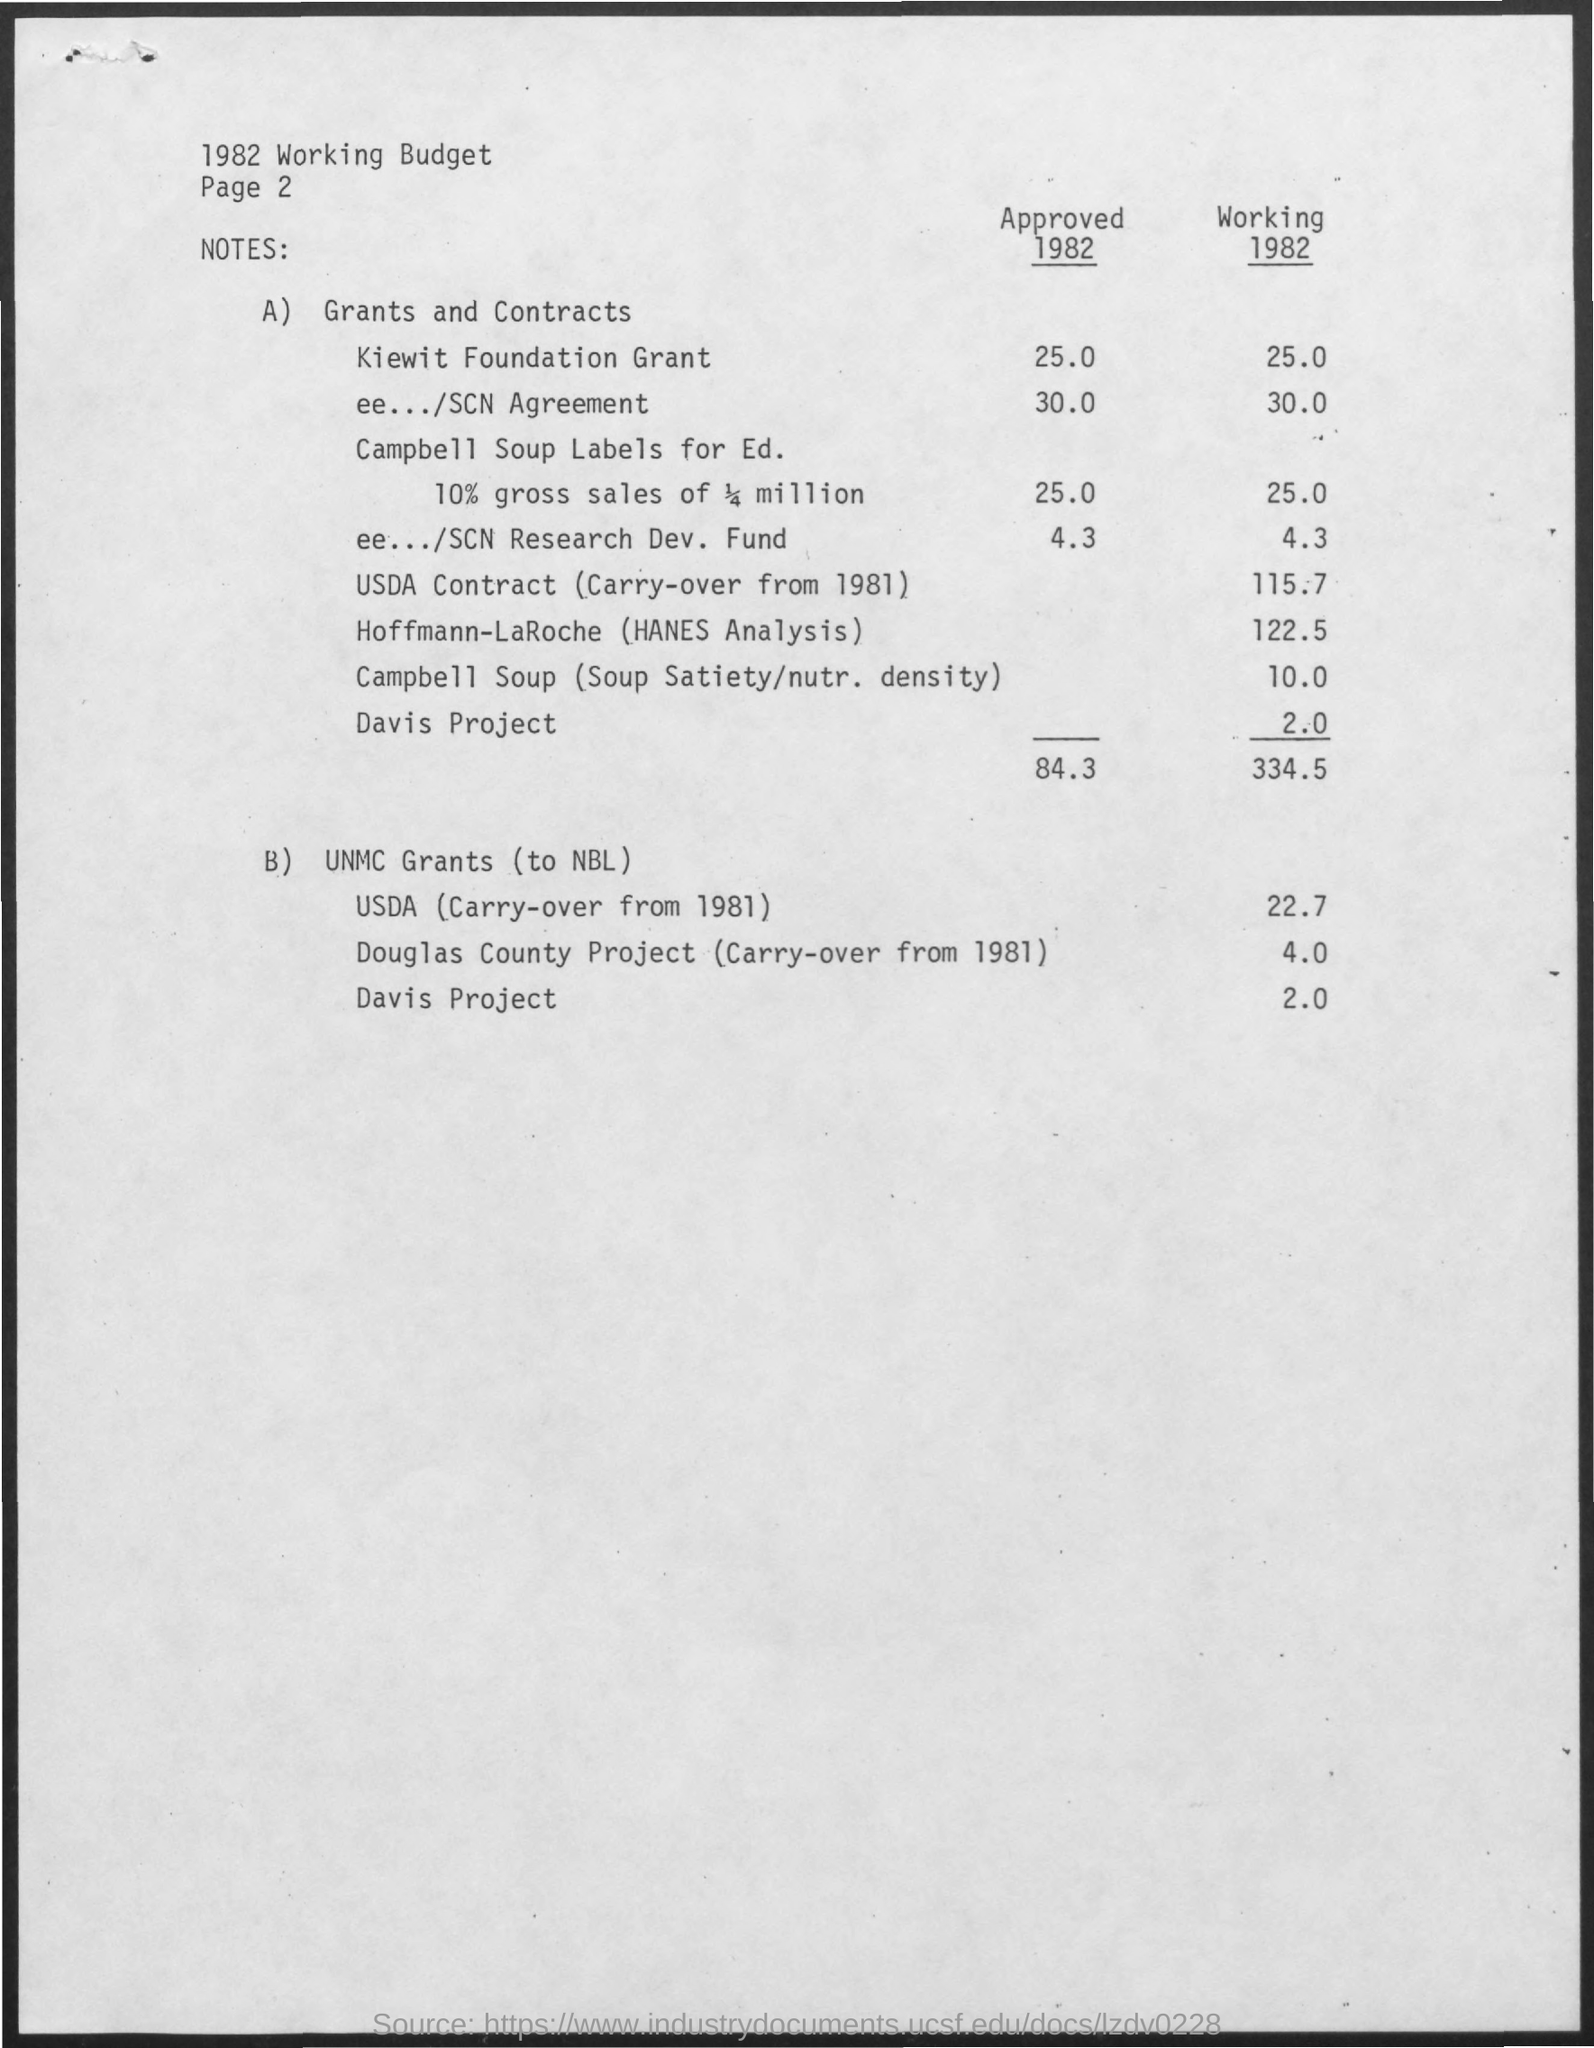What is the Title of the document?
Give a very brief answer. 1982 Working Budget. What is the Approved Budget 1982 for Kiewit Foundation Grant?
Offer a terse response. 25.0. What is the Working Budget 1982 for Kiewit Foundation Grant?
Offer a terse response. 25.0. What is the Working Budget 1982 for ee.../SCN Agreement?
Provide a succinct answer. 30.0. What is the Working Budget 1982 for USDA Contract (Carry over from 1981)?
Provide a short and direct response. 115.7. What is the Working Budget 1982 for Hoffmann-LaRoche (Hanes Analyssi)?
Offer a terse response. 122.5. What is the Working Budget 1982 for Campbell Soup (Soup Satiety/nutr. density)?
Provide a succinct answer. 10.0. What is the Working Budget 1982 for Davis Project?
Your response must be concise. 2.0. What is the Total Working Budget 1982?
Offer a very short reply. 334.5. What is the total Approved Budget 1982?
Give a very brief answer. 84.3. 